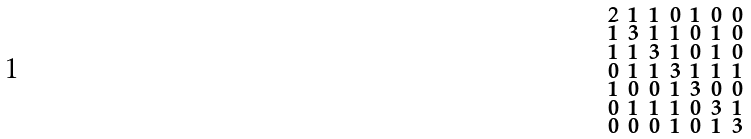Convert formula to latex. <formula><loc_0><loc_0><loc_500><loc_500>\begin{smallmatrix} 2 & 1 & 1 & 0 & 1 & 0 & 0 \\ 1 & 3 & 1 & 1 & 0 & 1 & 0 \\ 1 & 1 & 3 & 1 & 0 & 1 & 0 \\ 0 & 1 & 1 & 3 & 1 & 1 & 1 \\ 1 & 0 & 0 & 1 & 3 & 0 & 0 \\ 0 & 1 & 1 & 1 & 0 & 3 & 1 \\ 0 & 0 & 0 & 1 & 0 & 1 & 3 \end{smallmatrix}</formula> 